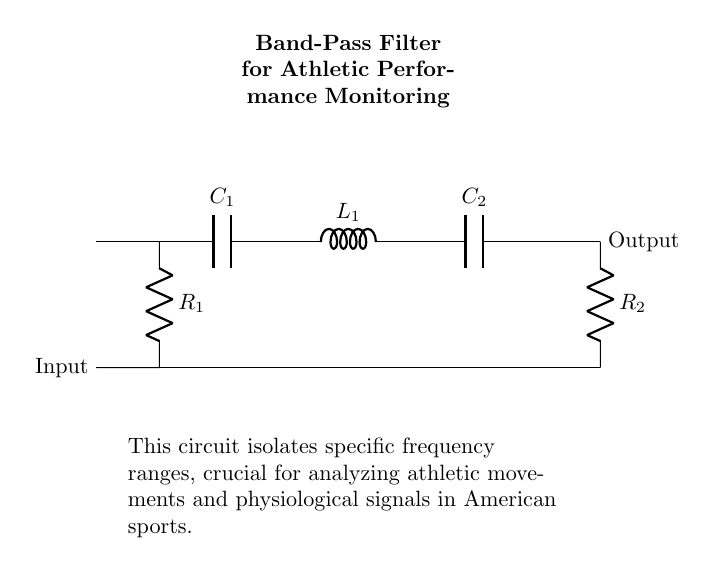What components are present in the circuit? The circuit includes a capacitor labeled C1, an inductor labeled L1, a second capacitor labeled C2, and two resistors labeled R1 and R2.
Answer: Capacitor, Inductor, Resistor What is the input connection of this circuit? The input connection is marked on the left side of the circuit diagram, where the resistor R1 connects to the rest of the circuit.
Answer: R1 What is the output connection of this circuit? The output connection is marked on the right side of the circuit diagram, where the signal exits after passing through the inductor and capacitors.
Answer: Output How many resistors are present in the circuit? There are two resistors in the circuit, R1 and R2, which are placed in different sections of the circuit.
Answer: 2 What is the purpose of this band-pass filter? The band-pass filter is designed to isolate specific frequency ranges, which is critical for analyzing athletic movements and physiological signals in American sports.
Answer: Isolate frequencies How does the circuit allow frequencies to pass? The circuit is designed with capacitors and an inductor such that it combines their properties to only permit frequencies within a certain range (band) while rejecting those outside it.
Answer: Pass specific frequencies What role does the inductor play in this filter? The inductor L1 in this circuit plays a crucial role in selecting frequency ranges; it allows certain frequencies to pass while obstructing others, creating a band-pass effect.
Answer: Frequency selection 